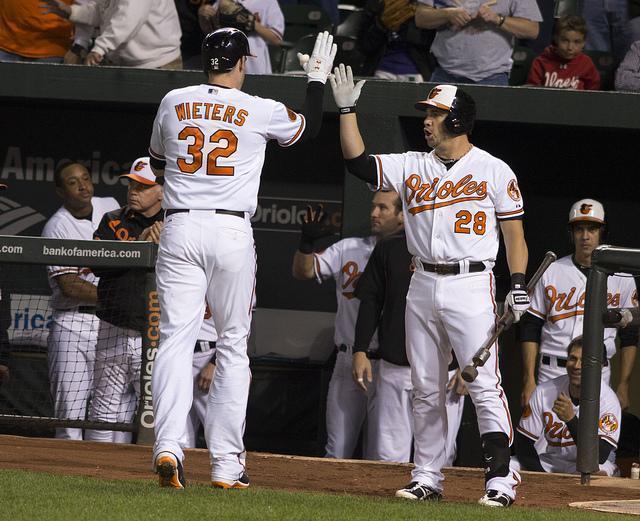What are the players here likely celebrating?
Pick the correct solution from the four options below to address the question.
Options: Break time, raise, homerun, bonus. Homerun. 